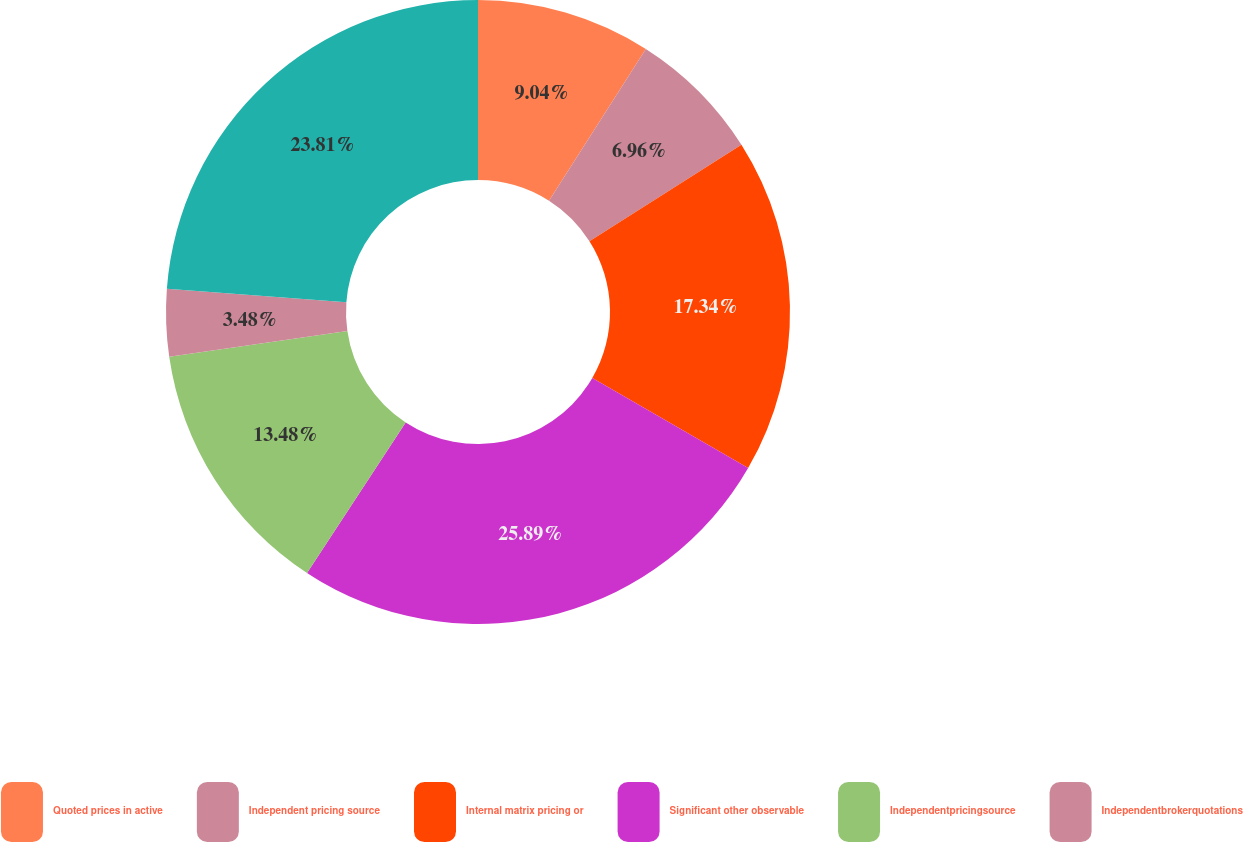<chart> <loc_0><loc_0><loc_500><loc_500><pie_chart><fcel>Quoted prices in active<fcel>Independent pricing source<fcel>Internal matrix pricing or<fcel>Significant other observable<fcel>Independentpricingsource<fcel>Independentbrokerquotations<fcel>Unnamed: 6<nl><fcel>9.04%<fcel>6.96%<fcel>17.34%<fcel>25.89%<fcel>13.48%<fcel>3.48%<fcel>23.81%<nl></chart> 